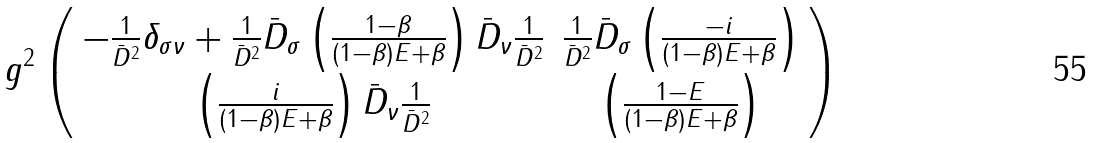Convert formula to latex. <formula><loc_0><loc_0><loc_500><loc_500>g ^ { 2 } \left ( \begin{array} { c c } { { - \frac { 1 } { \bar { D } ^ { 2 } } \delta _ { \sigma \nu } + \frac { 1 } { \bar { D } ^ { 2 } } \bar { D } _ { \sigma } \left ( \frac { 1 - \beta } { ( 1 - \beta ) E + \beta } \right ) \bar { D } _ { \nu } \frac { 1 } { \bar { D } ^ { 2 } } } } & { { \frac { 1 } { \bar { D } ^ { 2 } } \bar { D } _ { \sigma } \left ( \frac { - i } { ( 1 - \beta ) E + \beta } \right ) } } \\ { { \left ( \frac { i } { ( 1 - \beta ) E + \beta } \right ) \bar { D } _ { \nu } \frac { 1 } { \bar { D } ^ { 2 } } } } & { { \left ( \frac { 1 - E } { ( 1 - \beta ) E + \beta } \right ) } } \end{array} \right )</formula> 